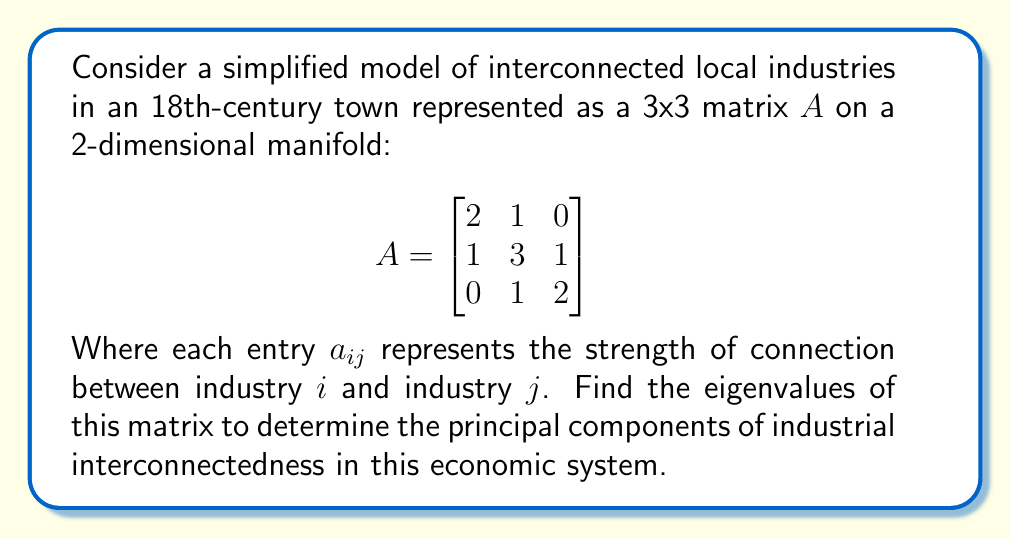Provide a solution to this math problem. To find the eigenvalues of matrix $A$, we need to solve the characteristic equation:

$\det(A - \lambda I) = 0$

Where $\lambda$ represents the eigenvalues and $I$ is the 3x3 identity matrix.

Step 1: Subtract $\lambda I$ from $A$:

$$A - \lambda I = \begin{bmatrix}
2-\lambda & 1 & 0 \\
1 & 3-\lambda & 1 \\
0 & 1 & 2-\lambda
\end{bmatrix}$$

Step 2: Calculate the determinant:

$\det(A - \lambda I) = (2-\lambda)[(3-\lambda)(2-\lambda) - 1] - 1[1(2-\lambda) - 0] + 0$

$= (2-\lambda)[(6-5\lambda+\lambda^2) - 1] - [2-\lambda]$

$= (2-\lambda)(5-5\lambda+\lambda^2) - (2-\lambda)$

$= 10-10\lambda+2\lambda^2-5\lambda+5\lambda^2-\lambda^3-2+\lambda$

$= -\lambda^3+7\lambda^2-11\lambda+8$

Step 3: Set the determinant equal to zero and solve for $\lambda$:

$-\lambda^3+7\lambda^2-11\lambda+8 = 0$

This cubic equation can be factored as:

$-(\lambda-1)(\lambda-2)(\lambda-4) = 0$

Step 4: Solve for $\lambda$:

$\lambda = 1, 2,$ or $4$

These are the eigenvalues of matrix $A$.
Answer: The eigenvalues of the matrix $A$ are $\lambda_1 = 1$, $\lambda_2 = 2$, and $\lambda_3 = 4$. 